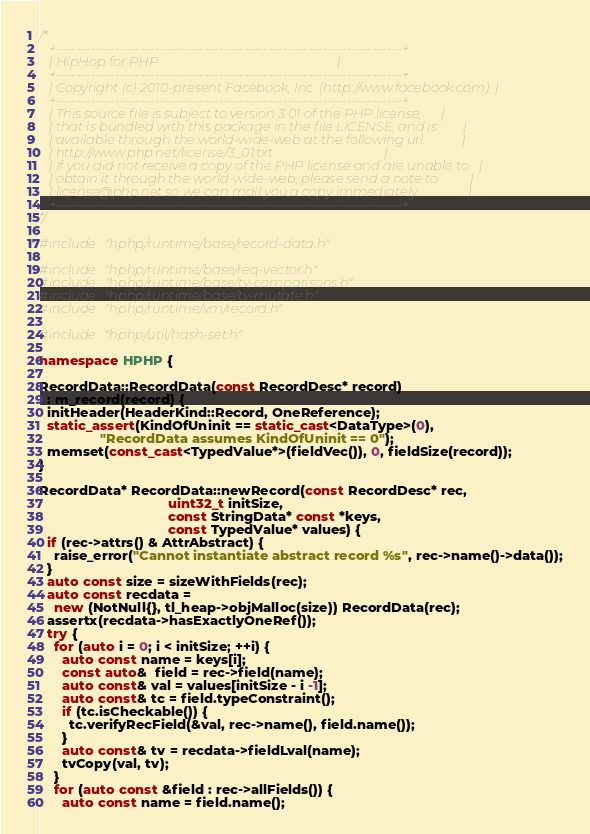Convert code to text. <code><loc_0><loc_0><loc_500><loc_500><_C++_>/*
   +----------------------------------------------------------------------+
   | HipHop for PHP                                                       |
   +----------------------------------------------------------------------+
   | Copyright (c) 2010-present Facebook, Inc. (http://www.facebook.com)  |
   +----------------------------------------------------------------------+
   | This source file is subject to version 3.01 of the PHP license,      |
   | that is bundled with this package in the file LICENSE, and is        |
   | available through the world-wide-web at the following url:           |
   | http://www.php.net/license/3_01.txt                                  |
   | If you did not receive a copy of the PHP license and are unable to   |
   | obtain it through the world-wide-web, please send a note to          |
   | license@php.net so we can mail you a copy immediately.               |
   +----------------------------------------------------------------------+
*/

#include "hphp/runtime/base/record-data.h"

#include "hphp/runtime/base/req-vector.h"
#include "hphp/runtime/base/tv-comparisons.h"
#include "hphp/runtime/base/tv-mutate.h"
#include "hphp/runtime/vm/record.h"

#include "hphp/util/hash-set.h"

namespace HPHP {

RecordData::RecordData(const RecordDesc* record)
  : m_record(record) {
  initHeader(HeaderKind::Record, OneReference);
  static_assert(KindOfUninit == static_cast<DataType>(0),
                "RecordData assumes KindOfUninit == 0");
  memset(const_cast<TypedValue*>(fieldVec()), 0, fieldSize(record));
}

RecordData* RecordData::newRecord(const RecordDesc* rec,
                                  uint32_t initSize,
                                  const StringData* const *keys,
                                  const TypedValue* values) {
  if (rec->attrs() & AttrAbstract) {
    raise_error("Cannot instantiate abstract record %s", rec->name()->data());
  }
  auto const size = sizeWithFields(rec);
  auto const recdata =
    new (NotNull{}, tl_heap->objMalloc(size)) RecordData(rec);
  assertx(recdata->hasExactlyOneRef());
  try {
    for (auto i = 0; i < initSize; ++i) {
      auto const name = keys[i];
      const auto&  field = rec->field(name);
      auto const& val = values[initSize - i -1];
      auto const& tc = field.typeConstraint();
      if (tc.isCheckable()) {
        tc.verifyRecField(&val, rec->name(), field.name());
      }
      auto const& tv = recdata->fieldLval(name);
      tvCopy(val, tv);
    }
    for (auto const &field : rec->allFields()) {
      auto const name = field.name();</code> 